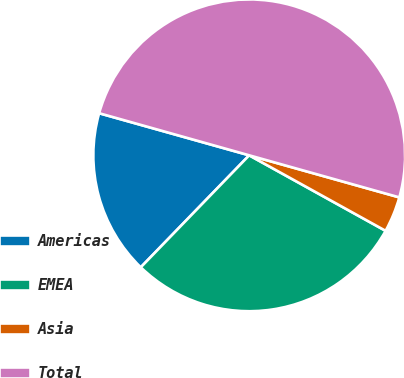Convert chart to OTSL. <chart><loc_0><loc_0><loc_500><loc_500><pie_chart><fcel>Americas<fcel>EMEA<fcel>Asia<fcel>Total<nl><fcel>17.11%<fcel>29.2%<fcel>3.7%<fcel>50.0%<nl></chart> 